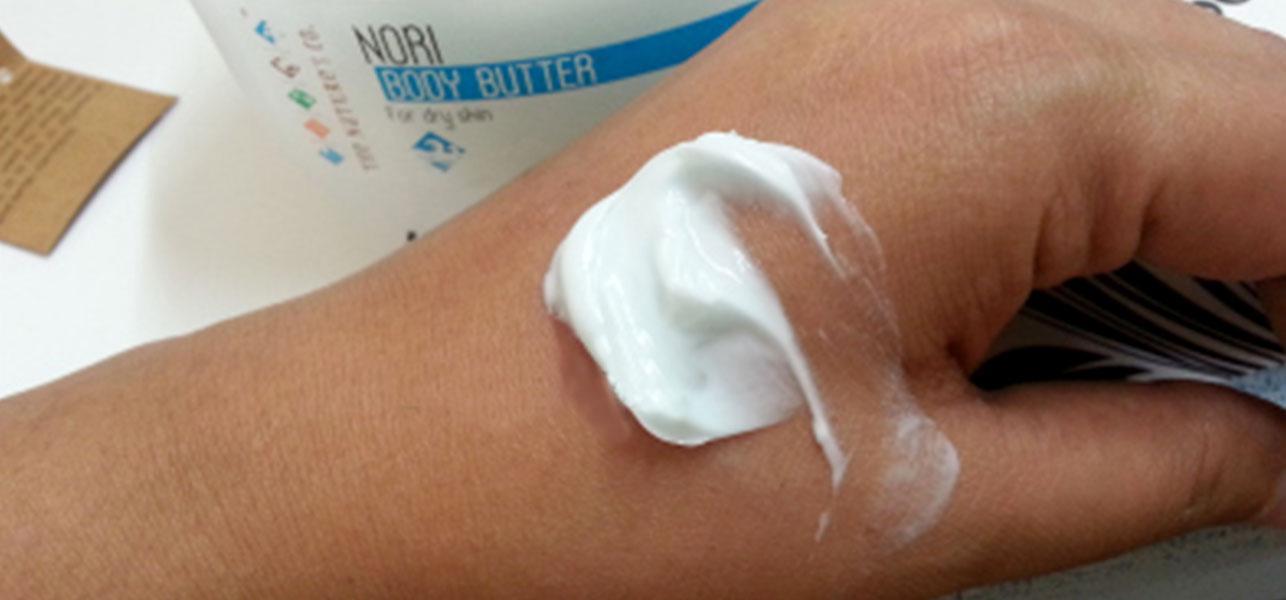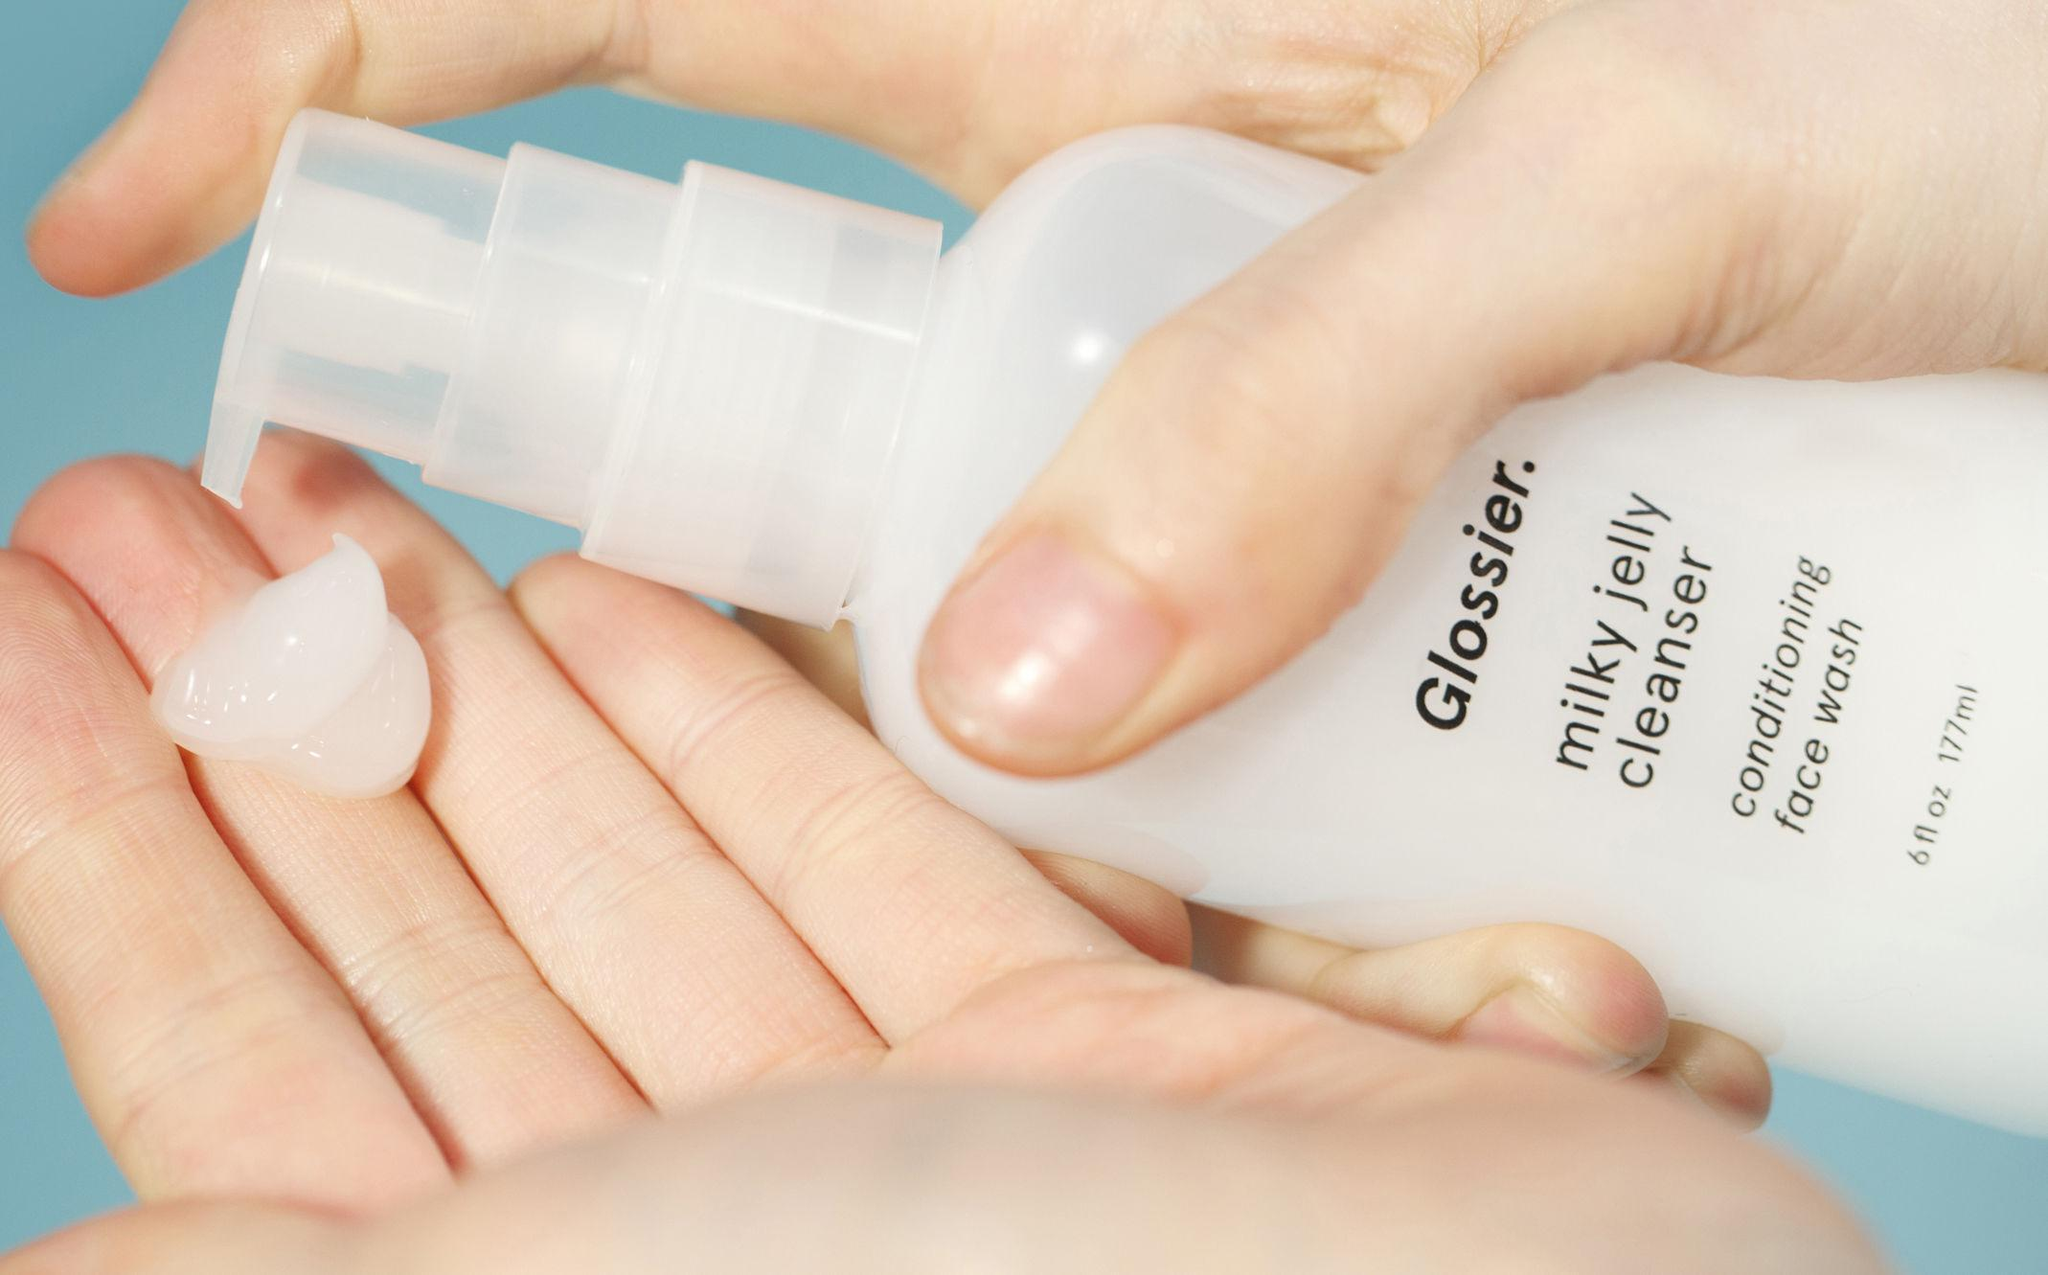The first image is the image on the left, the second image is the image on the right. Given the left and right images, does the statement "There are hands applying products in the images." hold true? Answer yes or no. Yes. The first image is the image on the left, the second image is the image on the right. Evaluate the accuracy of this statement regarding the images: "In at least one of the image, lotion is being applied to a hand.". Is it true? Answer yes or no. Yes. 